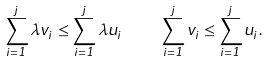<formula> <loc_0><loc_0><loc_500><loc_500>\sum _ { i = 1 } ^ { j } \lambda v _ { i } \leq \sum _ { i = 1 } ^ { j } \lambda u _ { i } \quad \sum _ { i = 1 } ^ { j } v _ { i } \leq \sum _ { i = 1 } ^ { j } u _ { i } .</formula> 